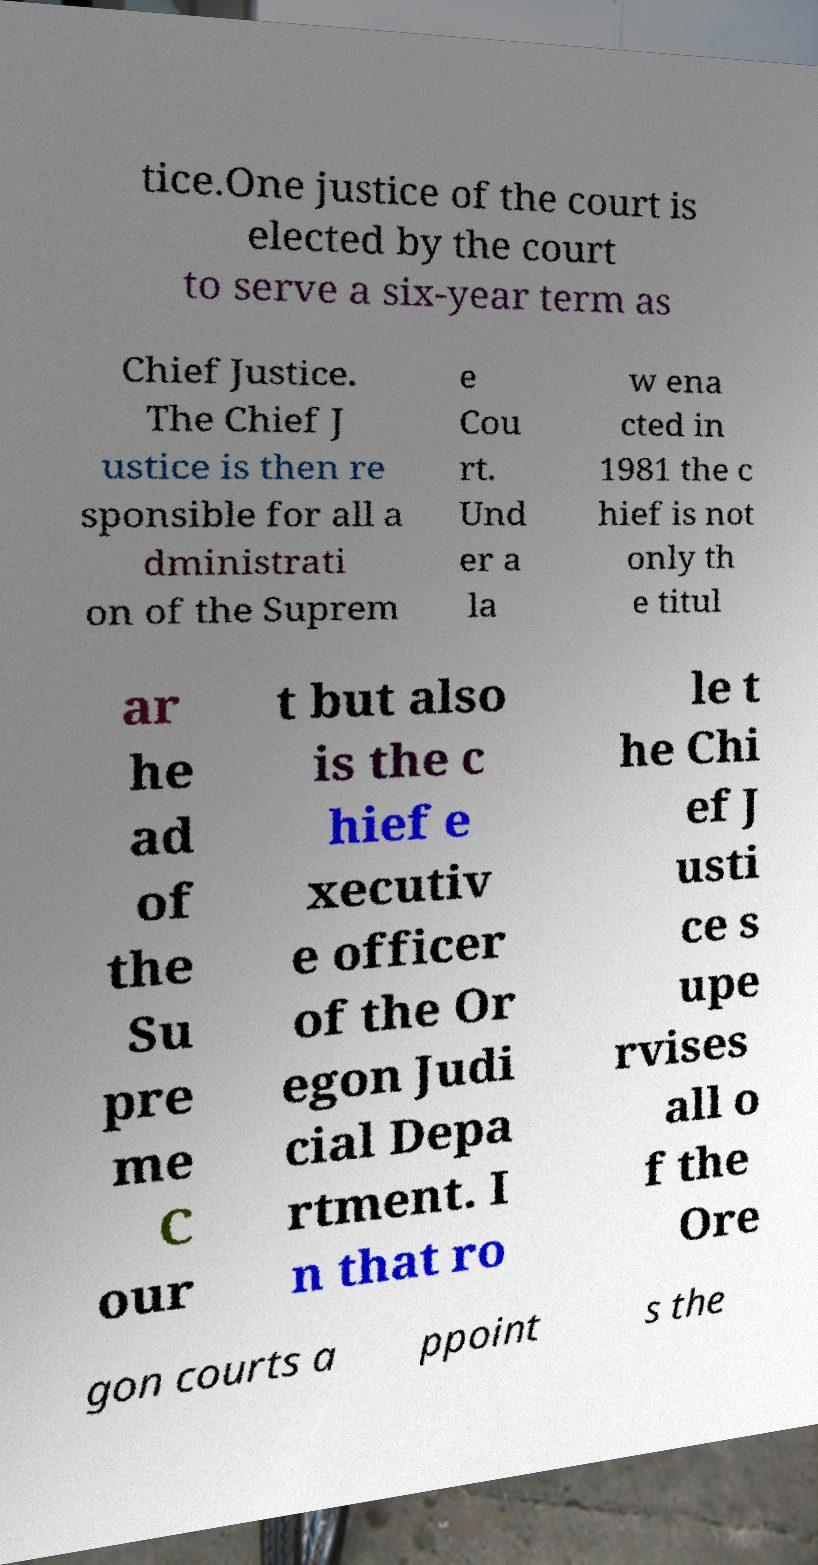Please read and relay the text visible in this image. What does it say? tice.One justice of the court is elected by the court to serve a six-year term as Chief Justice. The Chief J ustice is then re sponsible for all a dministrati on of the Suprem e Cou rt. Und er a la w ena cted in 1981 the c hief is not only th e titul ar he ad of the Su pre me C our t but also is the c hief e xecutiv e officer of the Or egon Judi cial Depa rtment. I n that ro le t he Chi ef J usti ce s upe rvises all o f the Ore gon courts a ppoint s the 